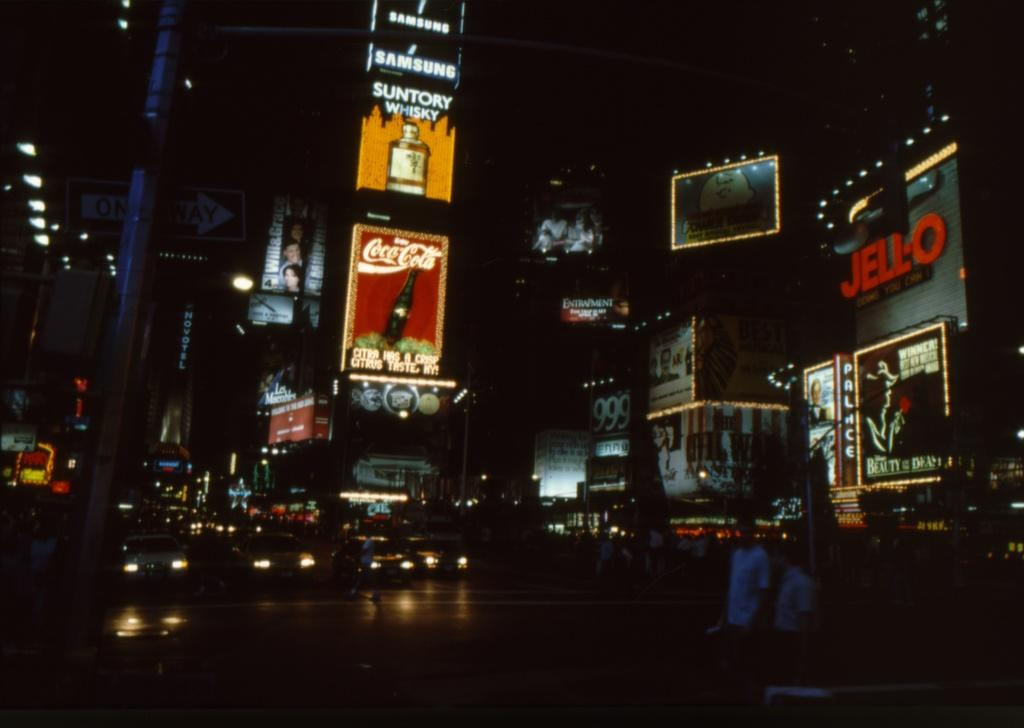What can be seen on the road in the image? There are vehicles on the road in the image. What is visible in the background of the image? There are buildings in the background of the image. What can be seen on the buildings in the image? There are advertisement banners on the buildings. What type of sand can be seen on the floor of the bedroom in the image? There is no bedroom or sand present in the image; it features vehicles on the road and buildings in the background. 